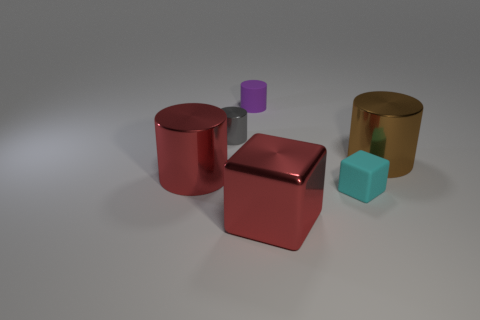Subtract all cyan cubes. How many cubes are left? 1 Subtract all big red metal cylinders. How many cylinders are left? 3 Subtract 3 cylinders. How many cylinders are left? 1 Subtract all brown cylinders. How many cyan blocks are left? 1 Add 4 big blue shiny blocks. How many big blue shiny blocks exist? 4 Add 1 tiny cyan objects. How many objects exist? 7 Subtract 0 green cylinders. How many objects are left? 6 Subtract all cylinders. How many objects are left? 2 Subtract all purple blocks. Subtract all gray spheres. How many blocks are left? 2 Subtract all tiny gray things. Subtract all purple rubber cylinders. How many objects are left? 4 